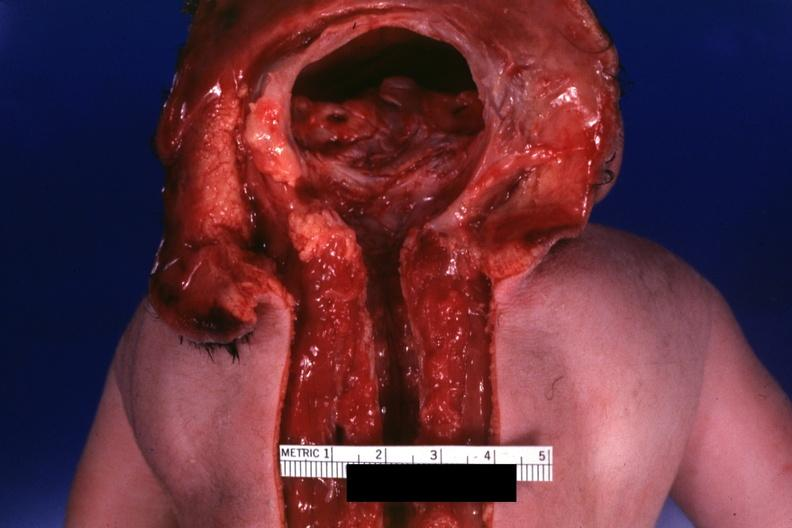what does this image show?
Answer the question using a single word or phrase. Dysraphism encephalocele occipital premature female no chromosomal defects lived one day 